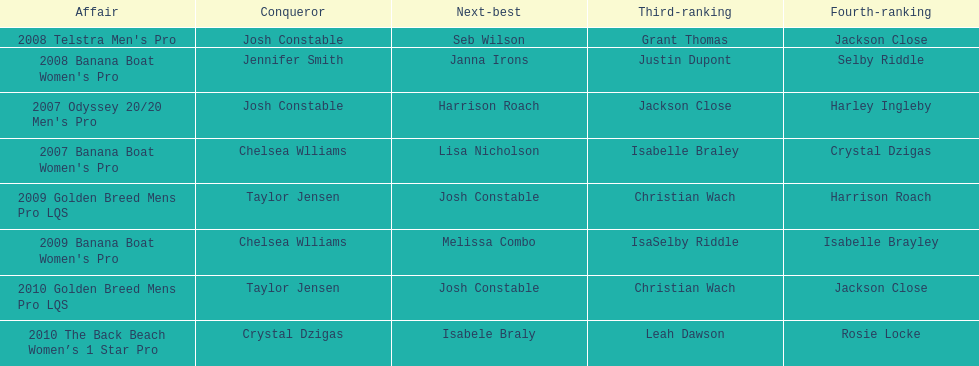In what two races did chelsea williams earn the same rank? 2007 Banana Boat Women's Pro, 2009 Banana Boat Women's Pro. 